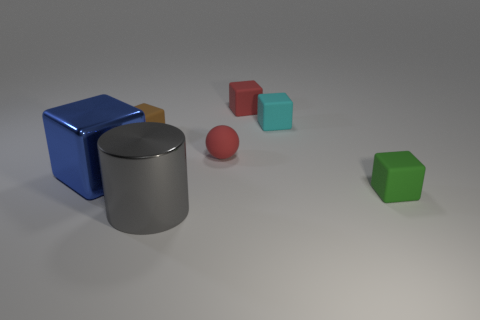Subtract all small red blocks. How many blocks are left? 4 Add 3 tiny cyan rubber objects. How many objects exist? 10 Subtract all red cubes. How many cubes are left? 4 Subtract 3 cubes. How many cubes are left? 2 Subtract all spheres. How many objects are left? 6 Subtract all brown matte blocks. Subtract all tiny brown rubber things. How many objects are left? 5 Add 2 small matte things. How many small matte things are left? 7 Add 7 tiny gray rubber objects. How many tiny gray rubber objects exist? 7 Subtract 0 purple balls. How many objects are left? 7 Subtract all blue blocks. Subtract all gray cylinders. How many blocks are left? 4 